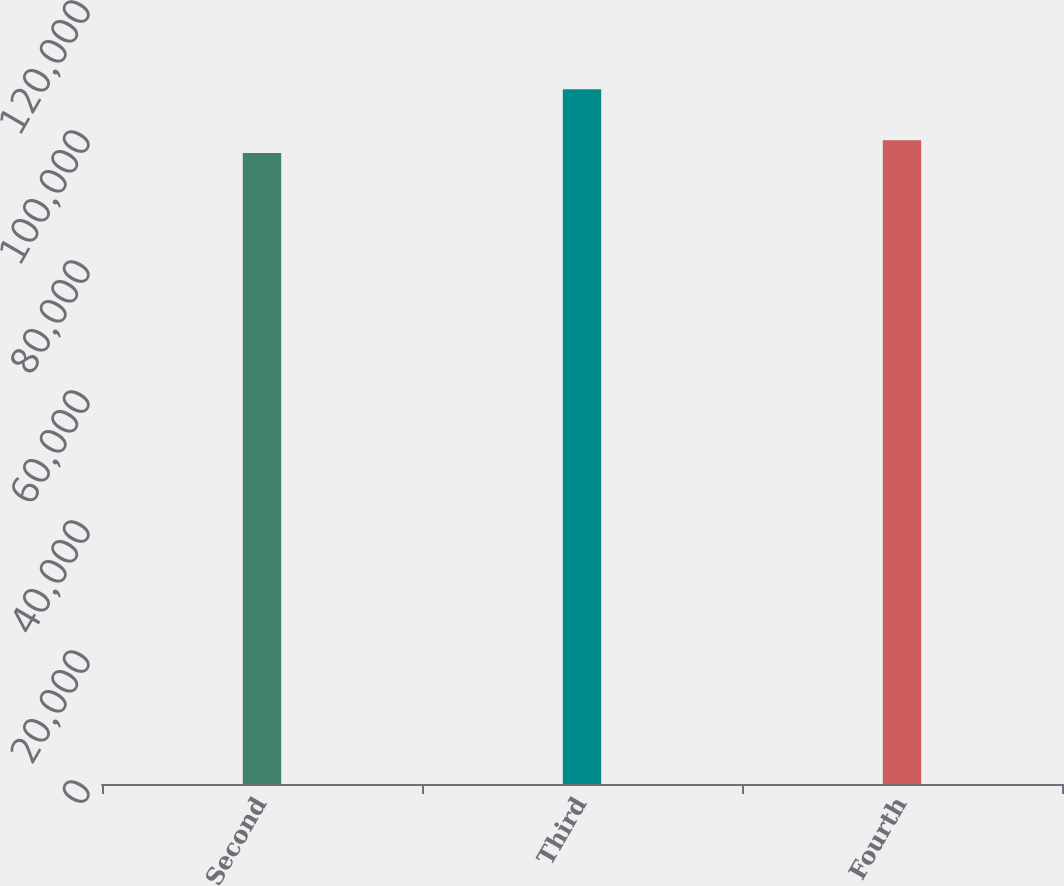<chart> <loc_0><loc_0><loc_500><loc_500><bar_chart><fcel>Second<fcel>Third<fcel>Fourth<nl><fcel>97080<fcel>106884<fcel>99046<nl></chart> 